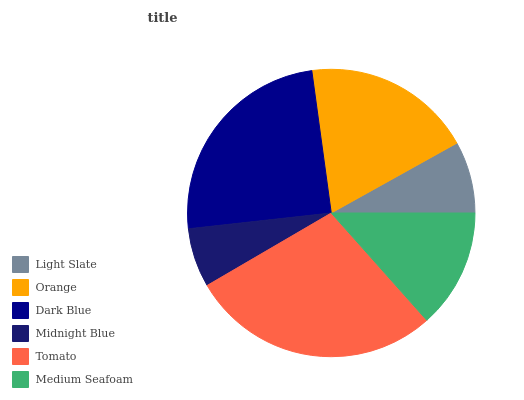Is Midnight Blue the minimum?
Answer yes or no. Yes. Is Tomato the maximum?
Answer yes or no. Yes. Is Orange the minimum?
Answer yes or no. No. Is Orange the maximum?
Answer yes or no. No. Is Orange greater than Light Slate?
Answer yes or no. Yes. Is Light Slate less than Orange?
Answer yes or no. Yes. Is Light Slate greater than Orange?
Answer yes or no. No. Is Orange less than Light Slate?
Answer yes or no. No. Is Orange the high median?
Answer yes or no. Yes. Is Medium Seafoam the low median?
Answer yes or no. Yes. Is Medium Seafoam the high median?
Answer yes or no. No. Is Midnight Blue the low median?
Answer yes or no. No. 